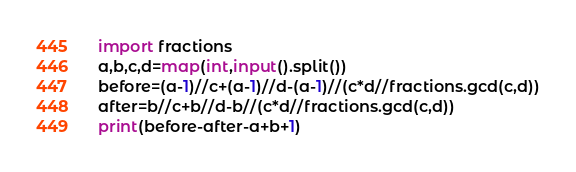<code> <loc_0><loc_0><loc_500><loc_500><_Python_>import fractions
a,b,c,d=map(int,input().split())
before=(a-1)//c+(a-1)//d-(a-1)//(c*d//fractions.gcd(c,d))
after=b//c+b//d-b//(c*d//fractions.gcd(c,d))
print(before-after-a+b+1)</code> 